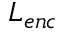<formula> <loc_0><loc_0><loc_500><loc_500>L _ { e n c }</formula> 